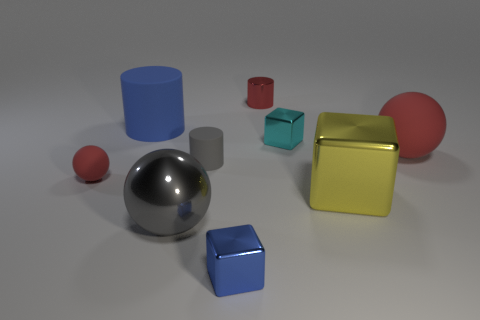There is a block that is the same color as the big cylinder; what material is it?
Give a very brief answer. Metal. There is a cyan shiny thing right of the gray metallic sphere; is its size the same as the blue matte cylinder?
Your response must be concise. No. There is a tiny metal cylinder that is behind the blue matte cylinder; is it the same color as the small matte sphere?
Your answer should be very brief. Yes. Is the red thing to the left of the small red shiny cylinder made of the same material as the big red sphere?
Your answer should be very brief. Yes. What number of things are small cyan metallic cubes or small metallic objects on the left side of the small cyan shiny cube?
Your response must be concise. 3. There is a red rubber ball that is left of the large metal object to the left of the small red shiny cylinder; how many large yellow objects are in front of it?
Give a very brief answer. 1. Do the red object on the right side of the yellow metallic thing and the big gray thing have the same shape?
Make the answer very short. Yes. Are there any large gray balls that are behind the tiny red rubber sphere in front of the blue matte object?
Provide a short and direct response. No. What number of large blue matte things are there?
Your response must be concise. 1. There is a ball that is behind the big gray ball and on the left side of the big red object; what color is it?
Offer a terse response. Red. 